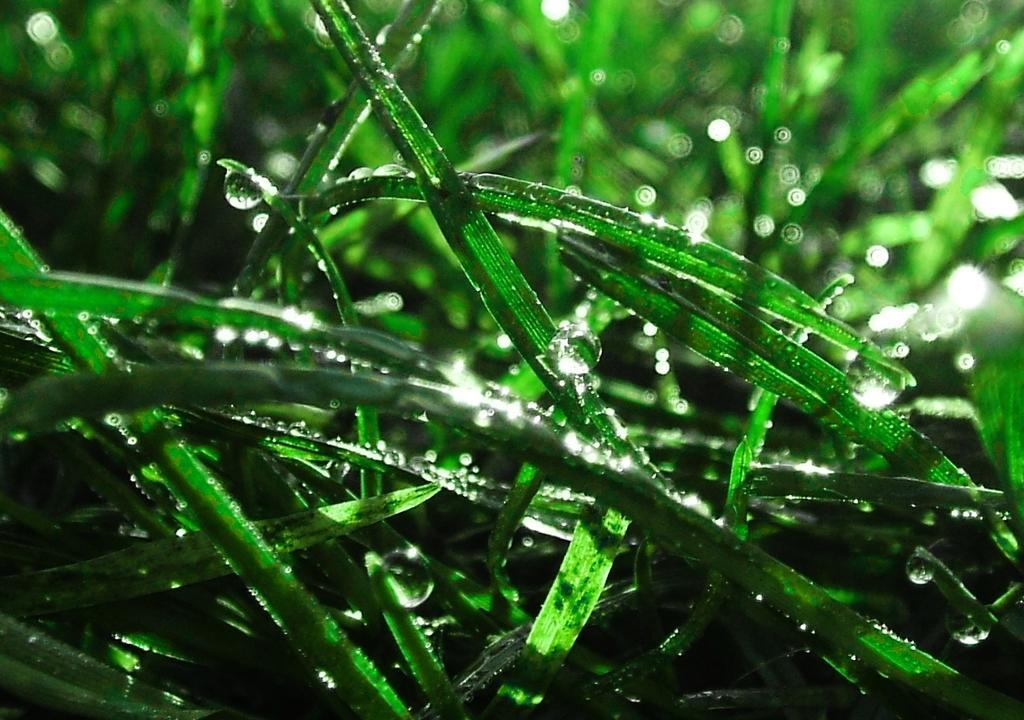How would you summarize this image in a sentence or two? This image consists of green grass along with water droplets. 